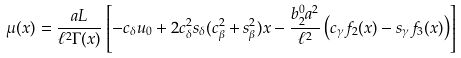Convert formula to latex. <formula><loc_0><loc_0><loc_500><loc_500>\mu ( x ) = \frac { a L } { \ell ^ { 2 } \Gamma ( x ) } \left [ - c _ { \delta } u _ { 0 } + 2 c _ { \delta } ^ { 2 } s _ { \delta } ( c _ { \beta } ^ { 2 } + s _ { \beta } ^ { 2 } ) x - \frac { b _ { 2 } ^ { 0 } a ^ { 2 } } { \ell ^ { 2 } } \left ( c _ { \gamma } f _ { 2 } ( x ) - s _ { \gamma } f _ { 3 } ( x ) \right ) \right ]</formula> 